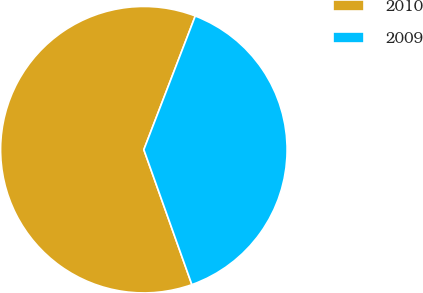<chart> <loc_0><loc_0><loc_500><loc_500><pie_chart><fcel>2010<fcel>2009<nl><fcel>61.29%<fcel>38.71%<nl></chart> 